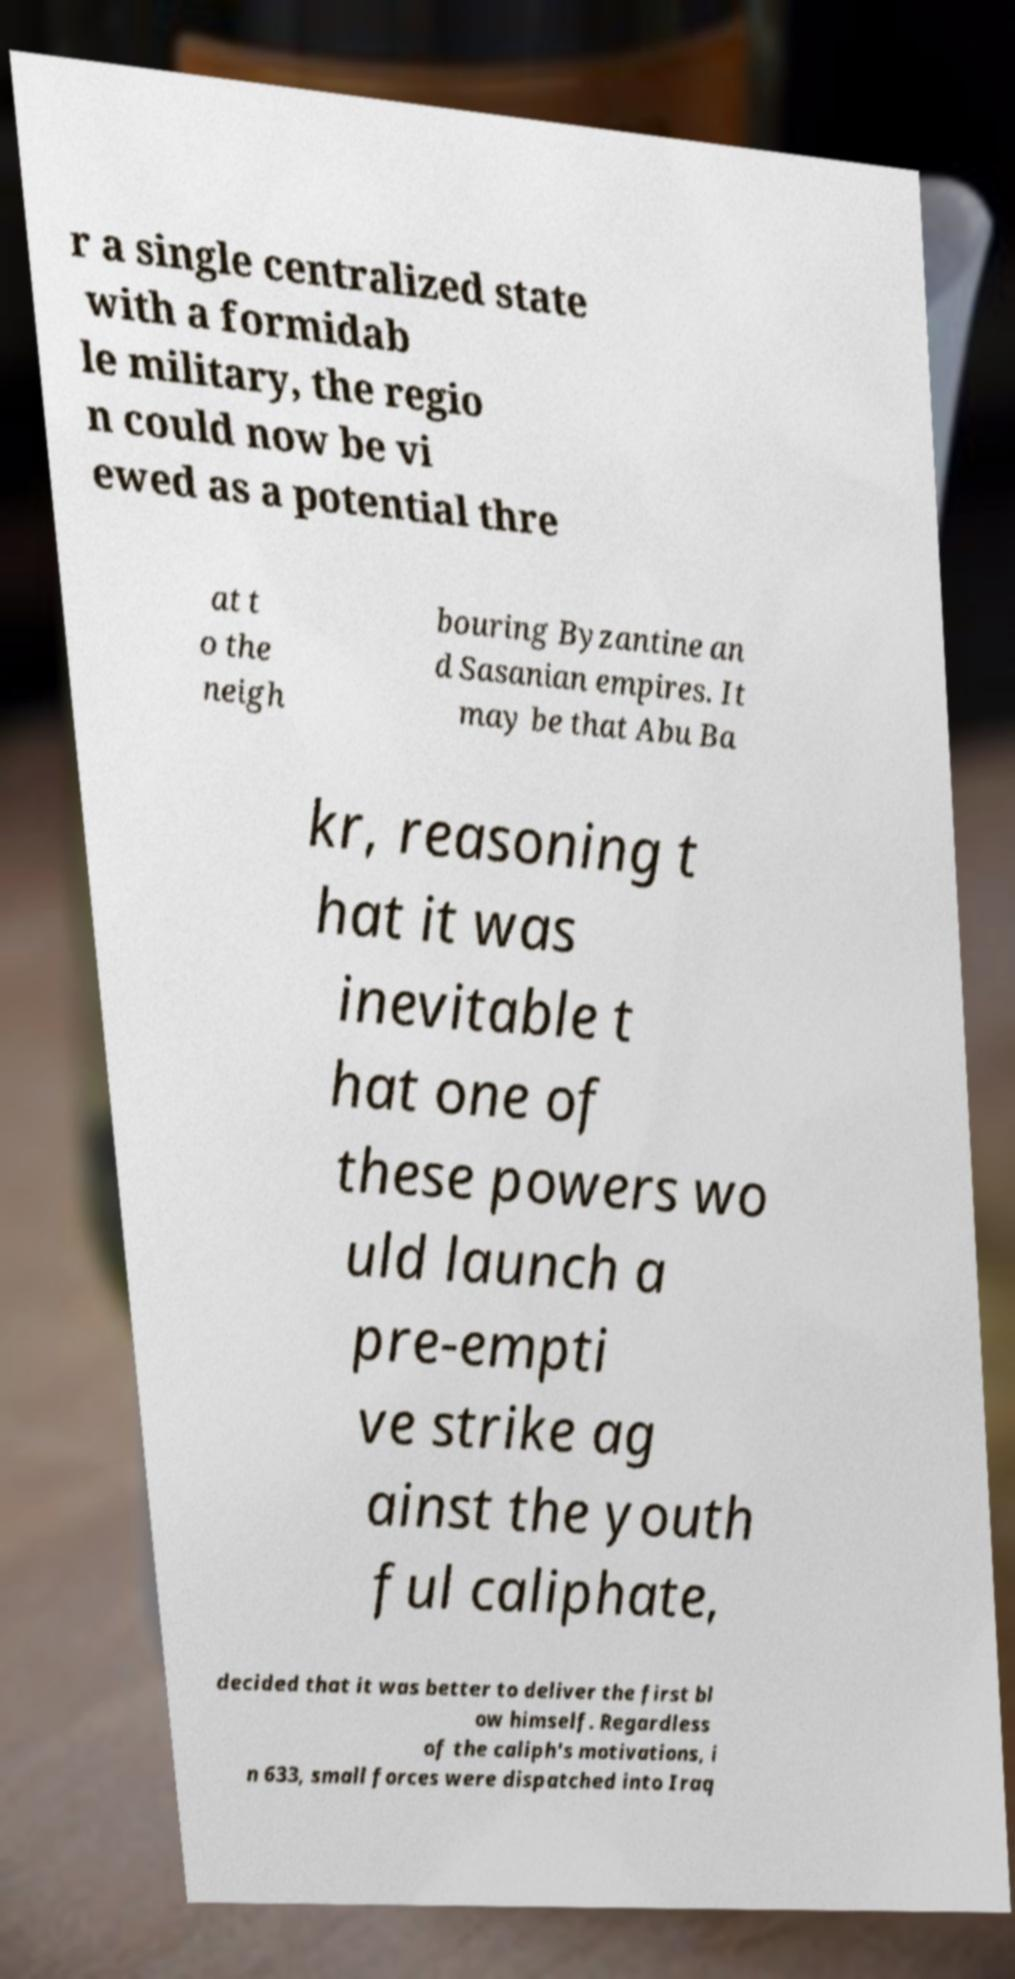I need the written content from this picture converted into text. Can you do that? r a single centralized state with a formidab le military, the regio n could now be vi ewed as a potential thre at t o the neigh bouring Byzantine an d Sasanian empires. It may be that Abu Ba kr, reasoning t hat it was inevitable t hat one of these powers wo uld launch a pre-empti ve strike ag ainst the youth ful caliphate, decided that it was better to deliver the first bl ow himself. Regardless of the caliph's motivations, i n 633, small forces were dispatched into Iraq 